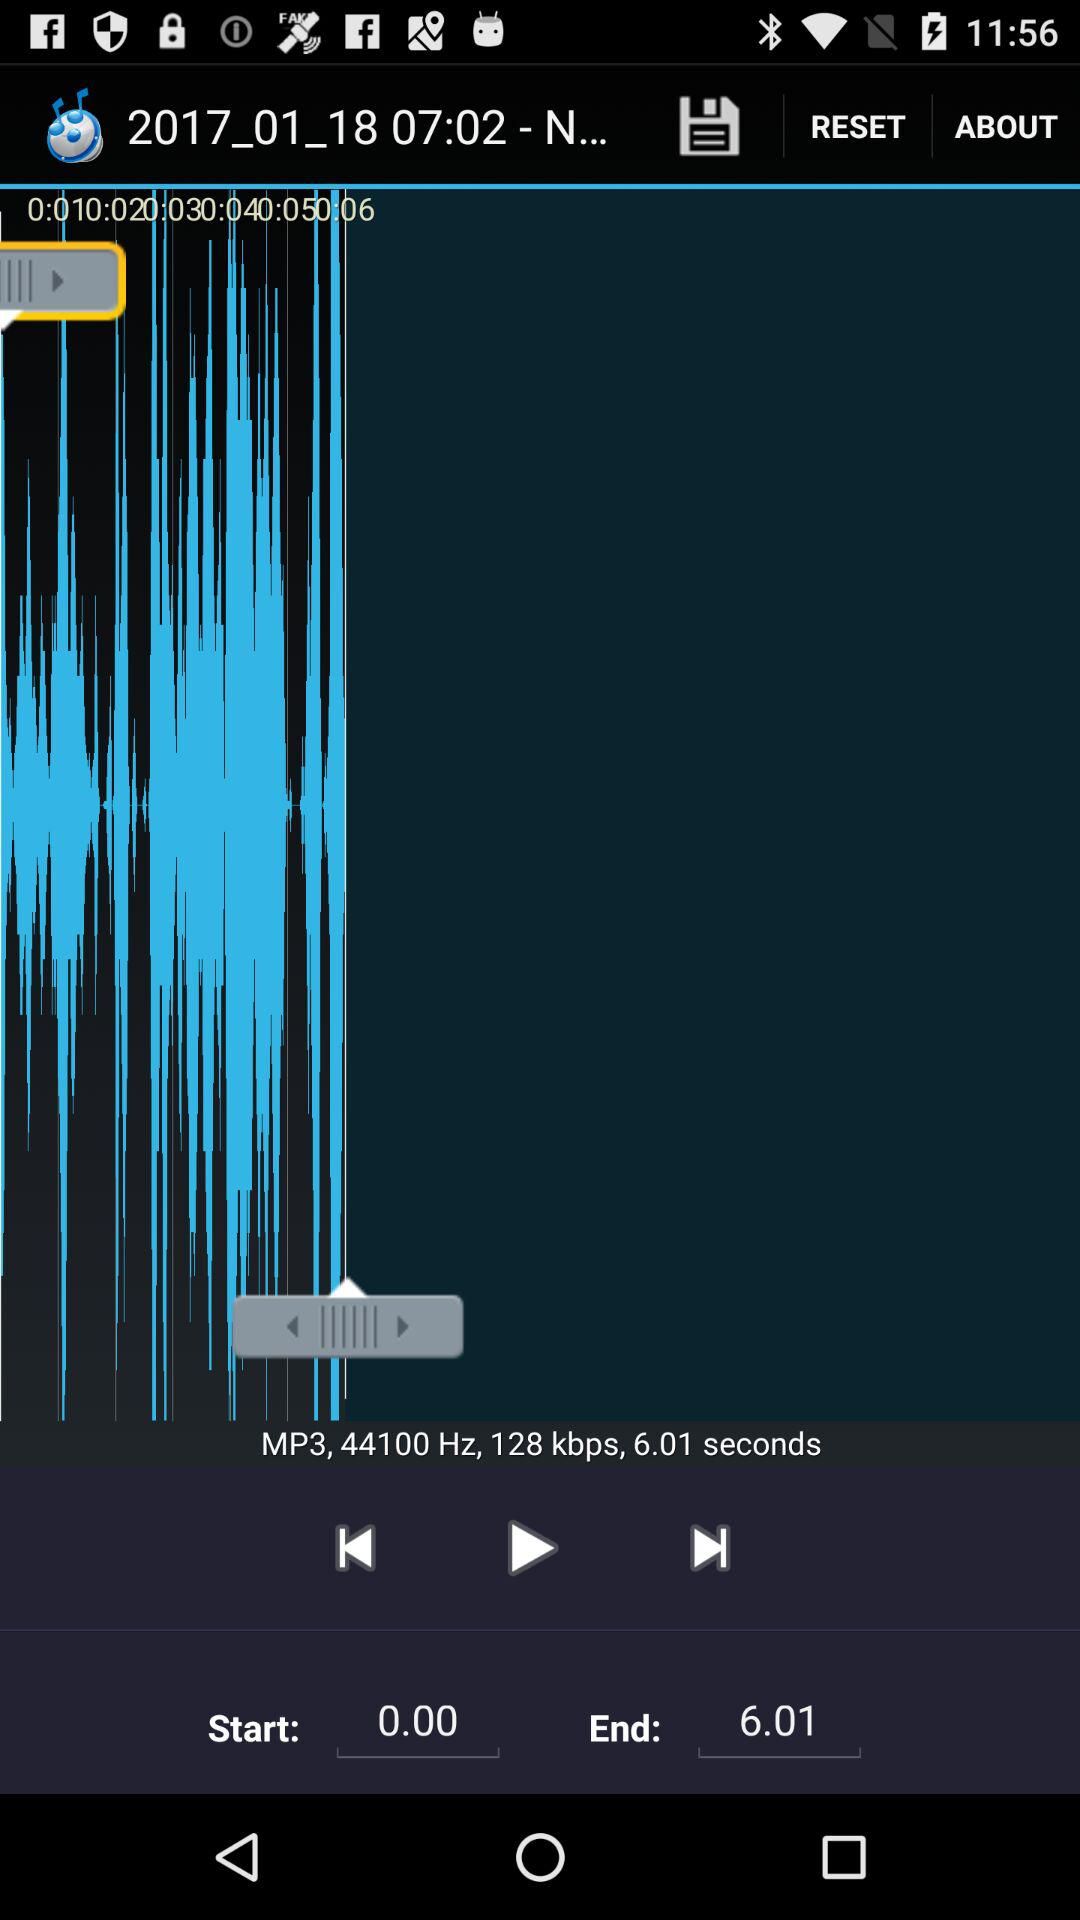What is the duration of the audio? The duration of the audio is 6.01 seconds. 